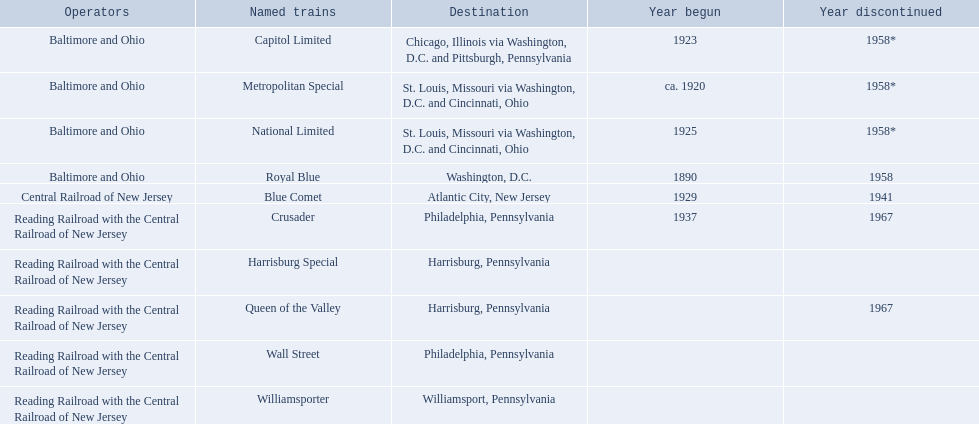What stops are included from the central railroad of new jersey terminal? Chicago, Illinois via Washington, D.C. and Pittsburgh, Pennsylvania, St. Louis, Missouri via Washington, D.C. and Cincinnati, Ohio, St. Louis, Missouri via Washington, D.C. and Cincinnati, Ohio, Washington, D.C., Atlantic City, New Jersey, Philadelphia, Pennsylvania, Harrisburg, Pennsylvania, Harrisburg, Pennsylvania, Philadelphia, Pennsylvania, Williamsport, Pennsylvania. Which of these stops appears first? Chicago, Illinois via Washington, D.C. and Pittsburgh, Pennsylvania. I'm looking to parse the entire table for insights. Could you assist me with that? {'header': ['Operators', 'Named trains', 'Destination', 'Year begun', 'Year discontinued'], 'rows': [['Baltimore and Ohio', 'Capitol Limited', 'Chicago, Illinois via Washington, D.C. and Pittsburgh, Pennsylvania', '1923', '1958*'], ['Baltimore and Ohio', 'Metropolitan Special', 'St. Louis, Missouri via Washington, D.C. and Cincinnati, Ohio', 'ca. 1920', '1958*'], ['Baltimore and Ohio', 'National Limited', 'St. Louis, Missouri via Washington, D.C. and Cincinnati, Ohio', '1925', '1958*'], ['Baltimore and Ohio', 'Royal Blue', 'Washington, D.C.', '1890', '1958'], ['Central Railroad of New Jersey', 'Blue Comet', 'Atlantic City, New Jersey', '1929', '1941'], ['Reading Railroad with the Central Railroad of New Jersey', 'Crusader', 'Philadelphia, Pennsylvania', '1937', '1967'], ['Reading Railroad with the Central Railroad of New Jersey', 'Harrisburg Special', 'Harrisburg, Pennsylvania', '', ''], ['Reading Railroad with the Central Railroad of New Jersey', 'Queen of the Valley', 'Harrisburg, Pennsylvania', '', '1967'], ['Reading Railroad with the Central Railroad of New Jersey', 'Wall Street', 'Philadelphia, Pennsylvania', '', ''], ['Reading Railroad with the Central Railroad of New Jersey', 'Williamsporter', 'Williamsport, Pennsylvania', '', '']]} 